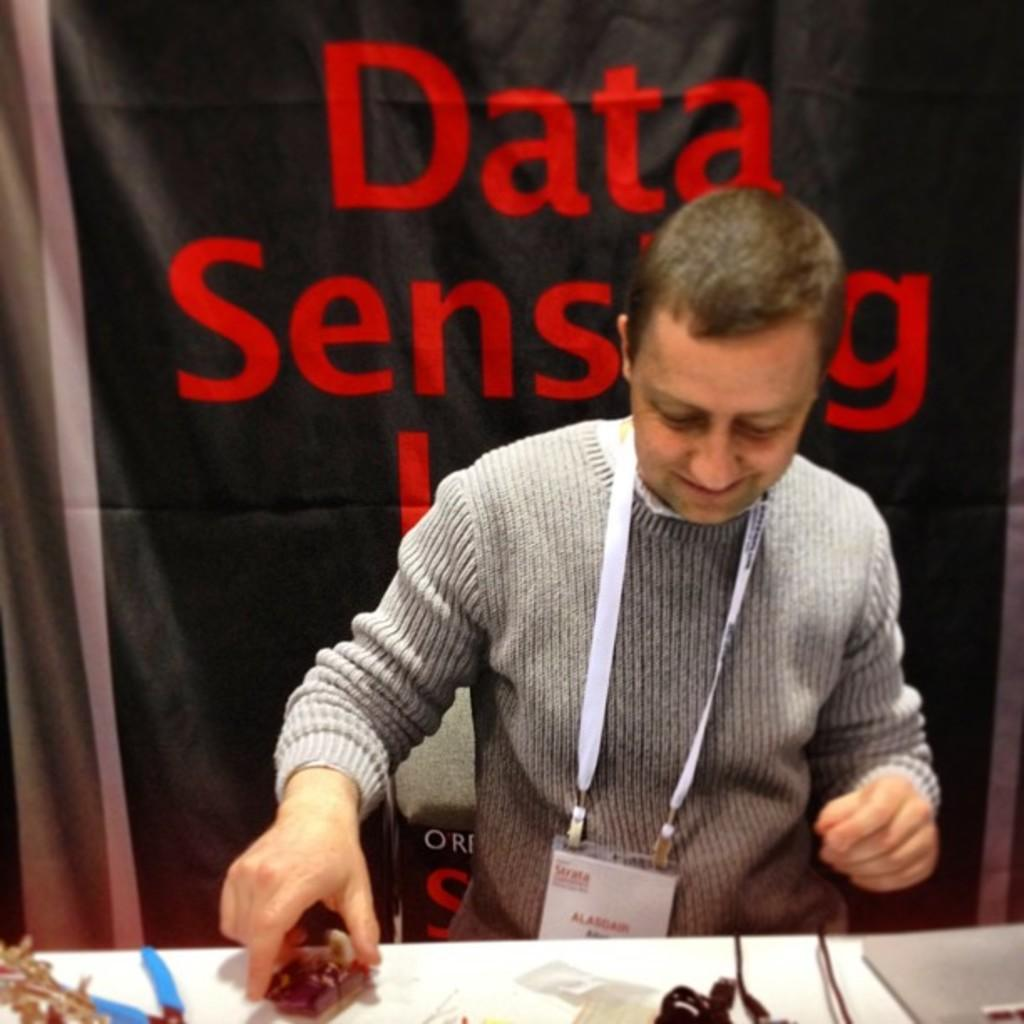Who is present in the image? There is a person in the image. What is the person wearing that can be identified in the image? The person is wearing an identity card. What can be seen on the table in the image? There are objects on a table in the image. What is hanging or displayed in the image? There is a banner in the image. What type of crime is being committed in the image? There is no indication of a crime being committed in the image. How many girls are present in the image? The provided facts do not mention any girls in the image. 